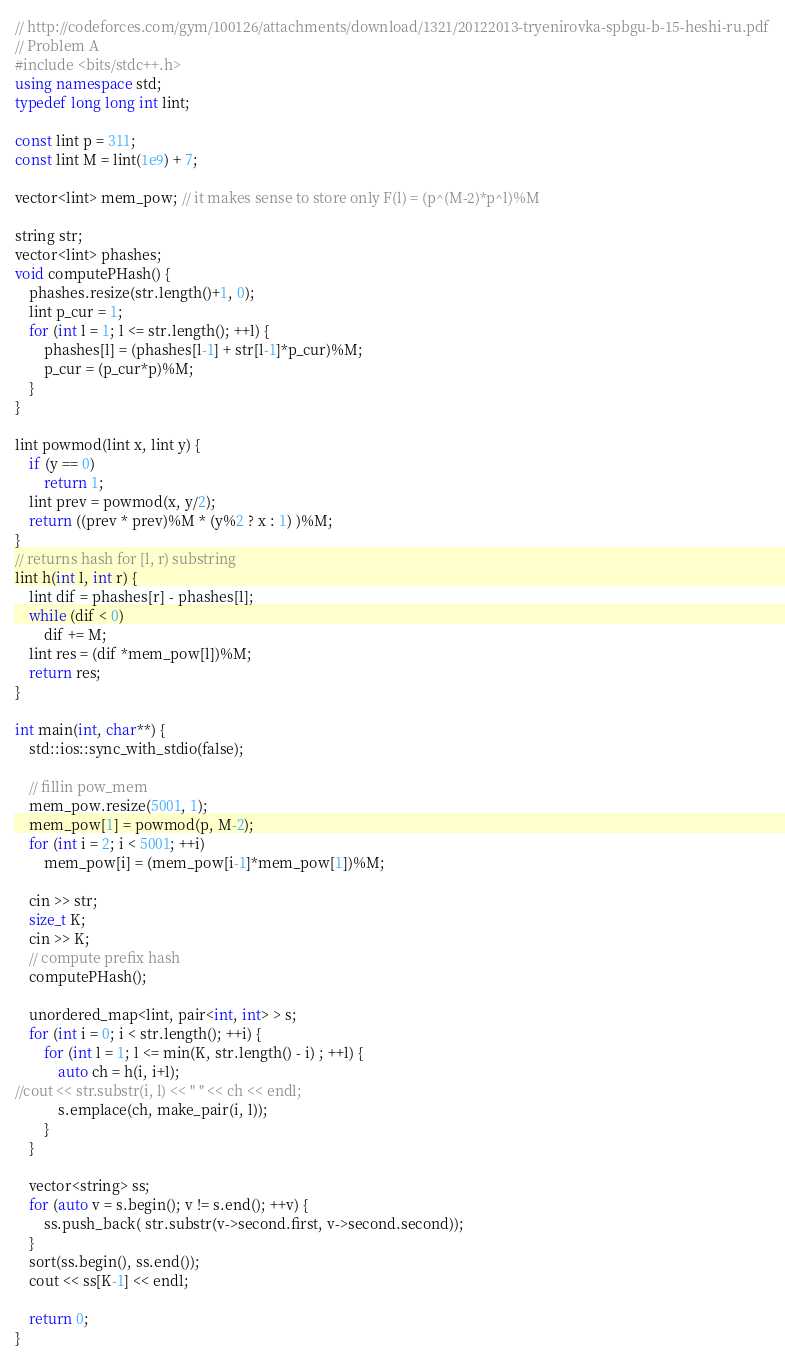<code> <loc_0><loc_0><loc_500><loc_500><_C++_>
// http://codeforces.com/gym/100126/attachments/download/1321/20122013-tryenirovka-spbgu-b-15-heshi-ru.pdf
// Problem A
#include <bits/stdc++.h>
using namespace std;
typedef long long int lint;

const lint p = 311;
const lint M = lint(1e9) + 7;

vector<lint> mem_pow; // it makes sense to store only F(l) = (p^(M-2)*p^l)%M

string str;
vector<lint> phashes;
void computePHash() {
    phashes.resize(str.length()+1, 0);
    lint p_cur = 1;
    for (int l = 1; l <= str.length(); ++l) {
        phashes[l] = (phashes[l-1] + str[l-1]*p_cur)%M;
        p_cur = (p_cur*p)%M;
    }
}

lint powmod(lint x, lint y) {
    if (y == 0)
        return 1;
    lint prev = powmod(x, y/2);
    return ((prev * prev)%M * (y%2 ? x : 1) )%M;
}
// returns hash for [l, r) substring
lint h(int l, int r) {
    lint dif = phashes[r] - phashes[l];
    while (dif < 0)
        dif += M;
    lint res = (dif *mem_pow[l])%M;
    return res;
}

int main(int, char**) {
    std::ios::sync_with_stdio(false);

    // fillin pow_mem
    mem_pow.resize(5001, 1);
    mem_pow[1] = powmod(p, M-2);
    for (int i = 2; i < 5001; ++i)
        mem_pow[i] = (mem_pow[i-1]*mem_pow[1])%M;    

    cin >> str;
    size_t K;
    cin >> K;
    // compute prefix hash
    computePHash();
    
    unordered_map<lint, pair<int, int> > s;
    for (int i = 0; i < str.length(); ++i) {
        for (int l = 1; l <= min(K, str.length() - i) ; ++l) {
            auto ch = h(i, i+l);
//cout << str.substr(i, l) << " " << ch << endl;
            s.emplace(ch, make_pair(i, l));     
        }
    }

    vector<string> ss;
    for (auto v = s.begin(); v != s.end(); ++v) {
        ss.push_back( str.substr(v->second.first, v->second.second));
    }
    sort(ss.begin(), ss.end());
    cout << ss[K-1] << endl;

    return 0;
}

</code> 